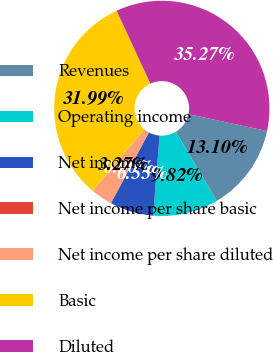Convert chart to OTSL. <chart><loc_0><loc_0><loc_500><loc_500><pie_chart><fcel>Revenues<fcel>Operating income<fcel>Net income<fcel>Net income per share basic<fcel>Net income per share diluted<fcel>Basic<fcel>Diluted<nl><fcel>13.1%<fcel>9.82%<fcel>6.55%<fcel>0.0%<fcel>3.27%<fcel>31.99%<fcel>35.27%<nl></chart> 